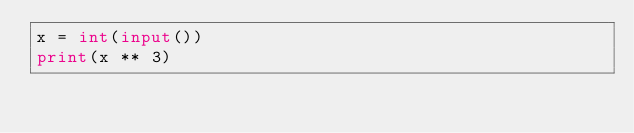<code> <loc_0><loc_0><loc_500><loc_500><_Python_>x = int(input())
print(x ** 3)

</code> 